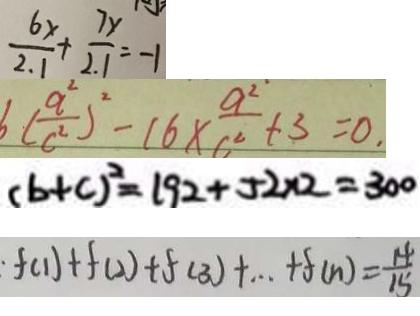Convert formula to latex. <formula><loc_0><loc_0><loc_500><loc_500>\frac { 6 x } { 2 . 1 } + \frac { 7 x } { 2 . 1 } = - 1 
 6 ( \frac { a ^ { 2 } } { c ^ { 2 } } ) ^ { 2 } - 1 6 \times \frac { a ^ { 2 } } { c ^ { 2 } } + 3 = 0 . 
 ( b + c ) ^ { 2 } = 1 9 2 + 5 2 \times 2 = 3 0 0 
 \cdot f ( 1 ) + f ( 2 ) + f ( 3 ) + \cdots + f ( n ) = \frac { 1 4 } { 1 5 }</formula> 